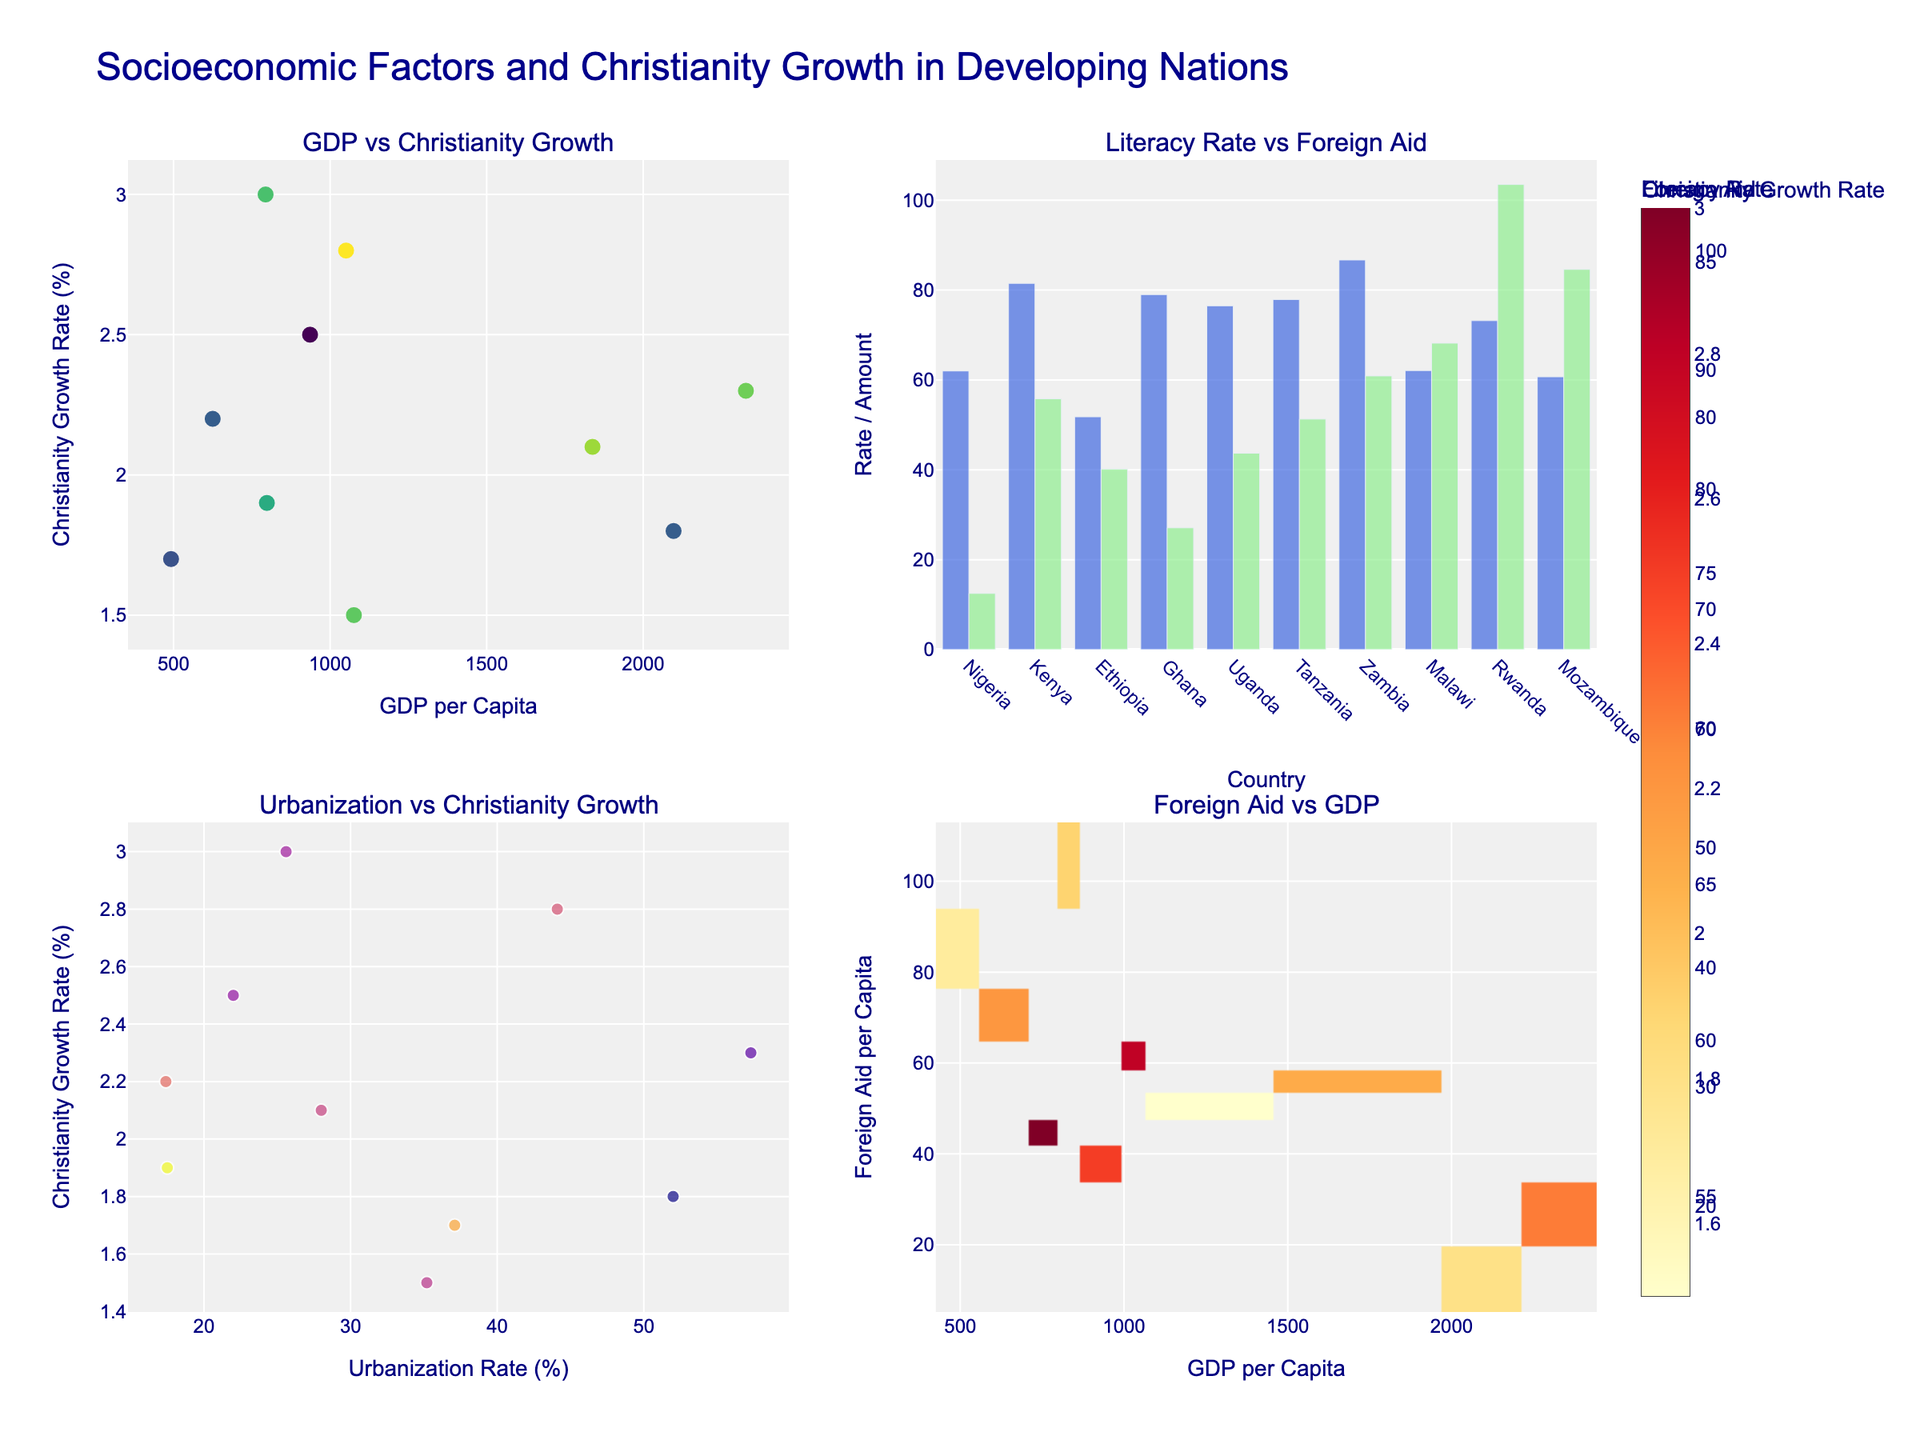What is the title of the figure? The title of the figure is clearly mentioned at the top of the plot. It reads, "Socioeconomic Factors and Christianity Growth in Developing Nations."
Answer: Socioeconomic Factors and Christianity Growth in Developing Nations Which country has the highest Literacy Rate? In the bar plot on the top-right, Literacy Rate bars are shown in blue. The highest bar corresponds to Zambia, indicating it has the highest Literacy Rate.
Answer: Zambia What is the GDP per capita of Uganda? In the scatter plot on the top-left, Uganda is one of the data points. By hovering over the data point representing Uganda, we can see that its GDP per capita is $794.
Answer: 794 Which country has the lowest Foreign Aid per capita? In the bar plot on the top-right, Foreign Aid bars are shown in light green. The smallest green bar corresponds to Nigeria.
Answer: Nigeria How does foreign aid correlate with Christianity growth in the heatmap? In the heatmap on the bottom-right, observe the color gradient which indicates the Christianity growth rates. Generally, one can see higher foreign aid per capita tends to correlate with darker colors (higher growth rates) indicating a positive correlation.
Answer: Positive correlation Which country has the largest bubble in the Urbanization vs. Christianity Growth rate subplot, and what does it represent? The largest bubble in the bubble plot on the bottom-left represents Ghana. The size of the bubble corresponds to GDP per capita, meaning Ghana has one of the higher GDP per capita values.
Answer: Ghana, higher GDP per capita Compare the Christianity growth rates in Ethiopia and Kenya. In the scatter plot on the top-left, hover over Ethiopia and Kenya to find their Christianity growth rates. Ethiopia has a growth rate of 2.5% while Kenya has a growth rate of 2.1%.
Answer: Ethiopia has a higher rate What does the color scale represent in the scatter plot showing GDP vs. Christianity Growth? The color scale in the scatter plot on the top-left represents Literacy Rate. Darker colors correspond to higher literacy rates.
Answer: Literacy Rate Which country has the highest urbanization rate and what is its Christianity growth rate? In the bubble plot on the bottom-left, the highest data point on the x-axis (urbanization rate) represents Ghana. By hovering over the data point, it shows Ghana has a Christianity growth rate of 2.3%.
Answer: Ghana, 2.3% What is the Christianity growth rate in countries with the highest GDP per capita? In the scatter plot on the top-left, identify the countries with the highest GDP per capita. Ghana has a GDP of 2328; its Christianity growth rate there is 2.3%.
Answer: 2.3% 